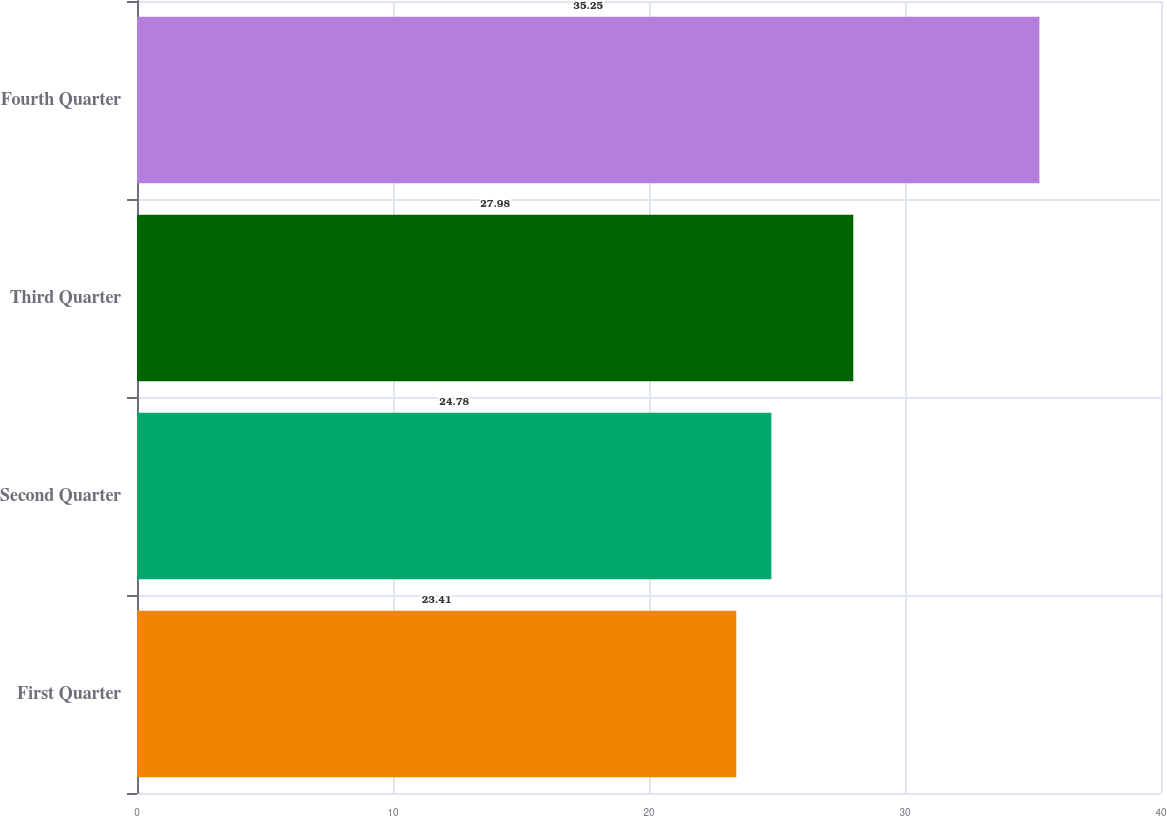Convert chart to OTSL. <chart><loc_0><loc_0><loc_500><loc_500><bar_chart><fcel>First Quarter<fcel>Second Quarter<fcel>Third Quarter<fcel>Fourth Quarter<nl><fcel>23.41<fcel>24.78<fcel>27.98<fcel>35.25<nl></chart> 